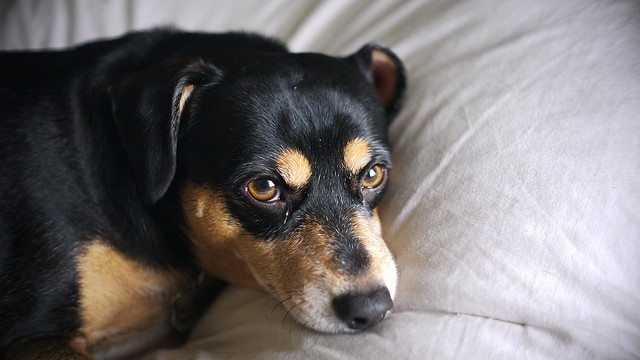Describe the objects in this image and their specific colors. I can see dog in black, gray, and maroon tones and bed in black, lavender, darkgray, and gray tones in this image. 